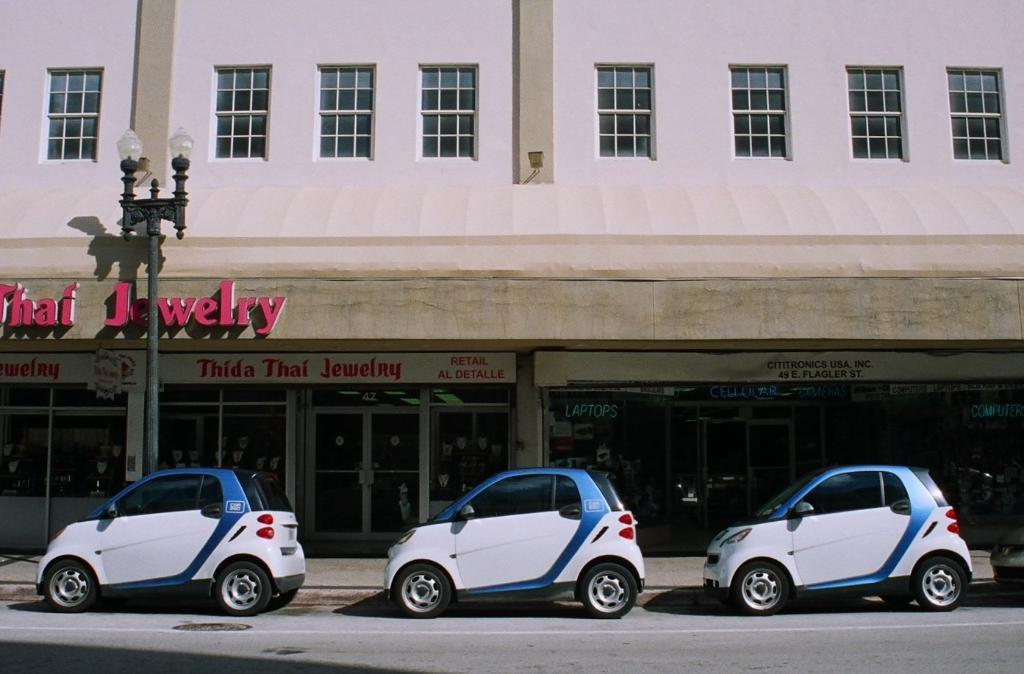What can be seen on the road in the image? There are vehicles on the road in the image. What type of structure is present in the image? There is a building in the image. What objects are visible in the image that might be used for displaying information or advertisements? There are boards in the image. What can be seen that might provide illumination in the image? There are lights in the image. What is the tall, vertical object in the image? There is a pole in the image. What type of lumber is being used to construct the building in the image? There is no information about the type of lumber used in the construction of the building in the image. How many dolls are sitting on the pole in the image? There are no dolls present in the image. 